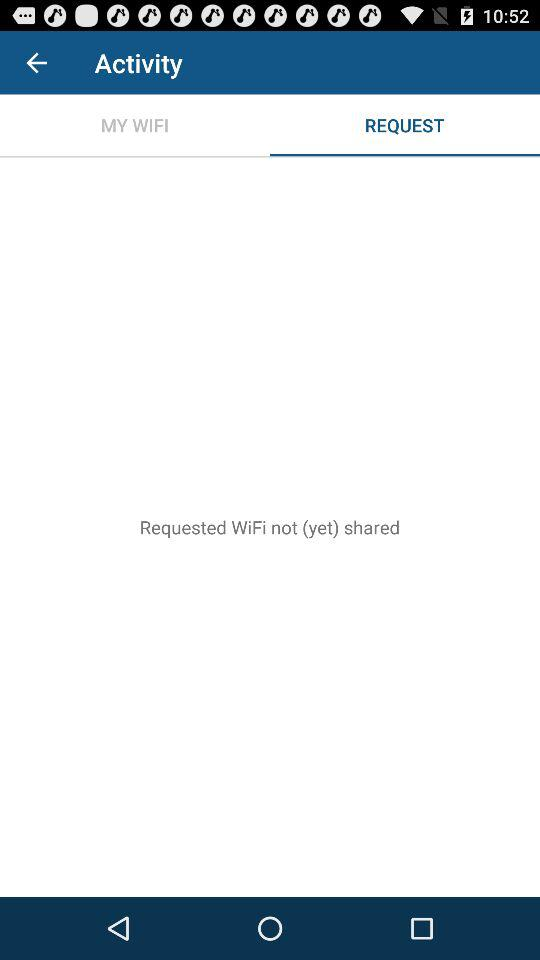Which tab is selected? The selected tab is "REQUEST". 